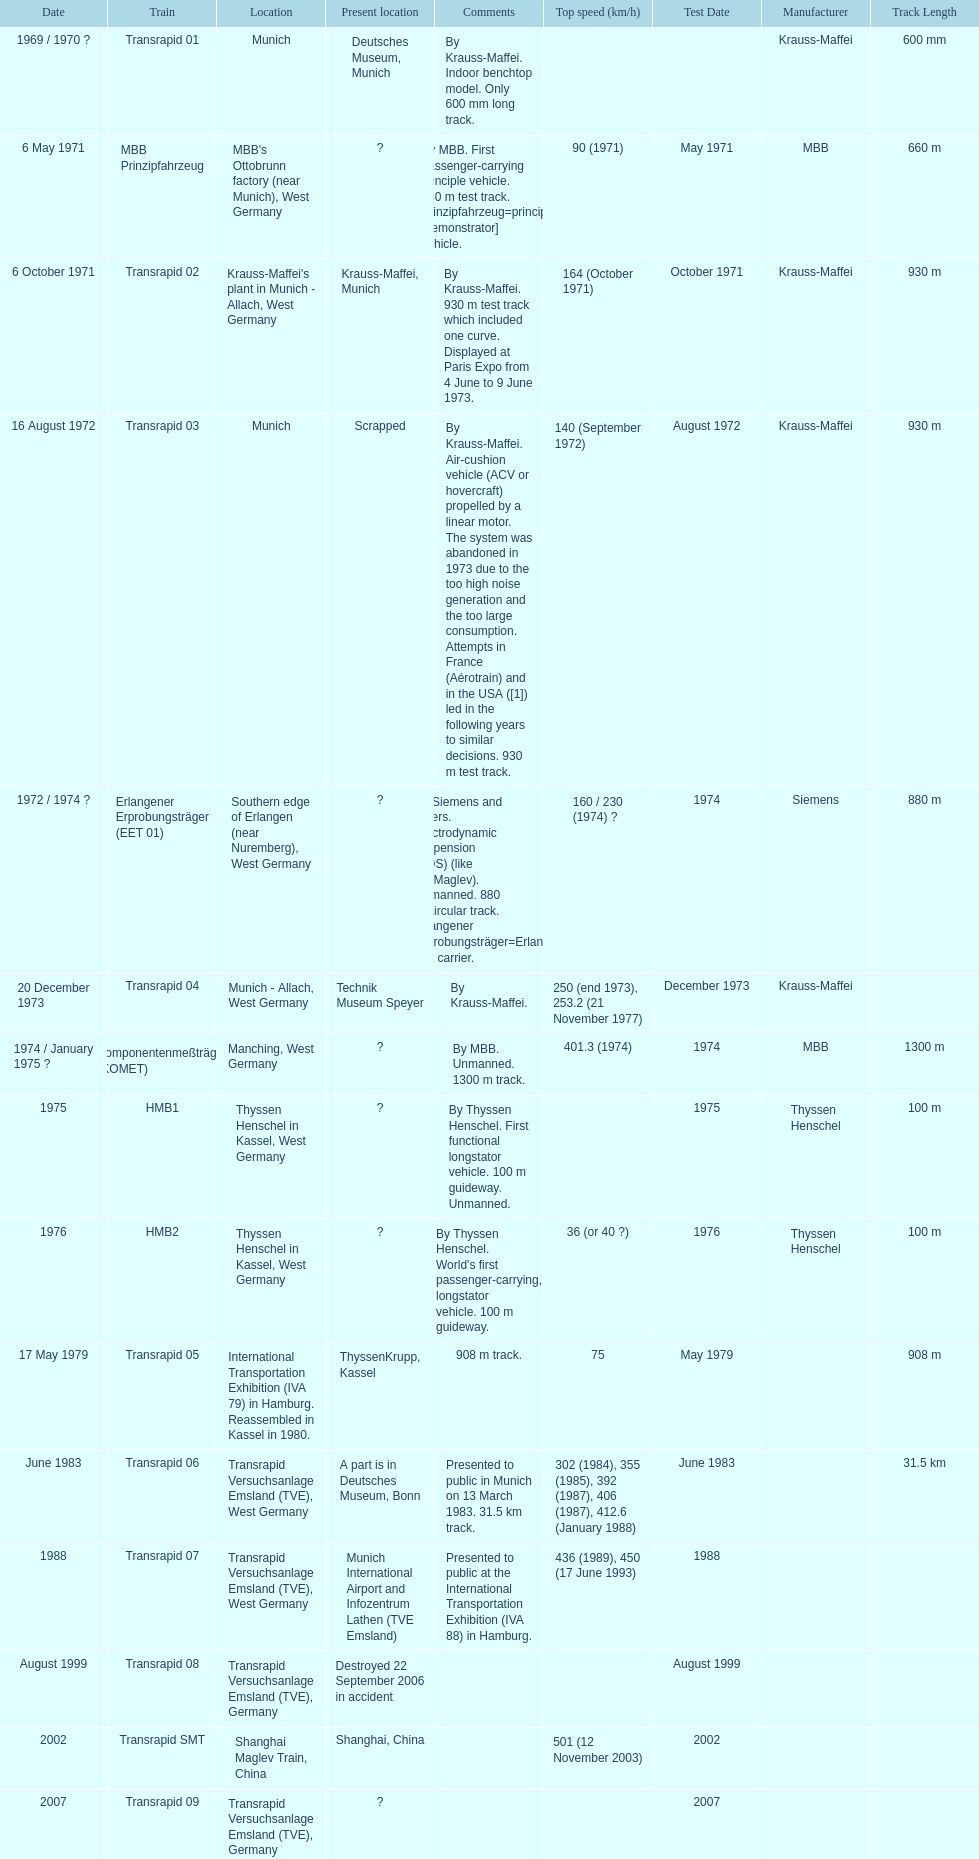Which train has the least top speed? HMB2. 